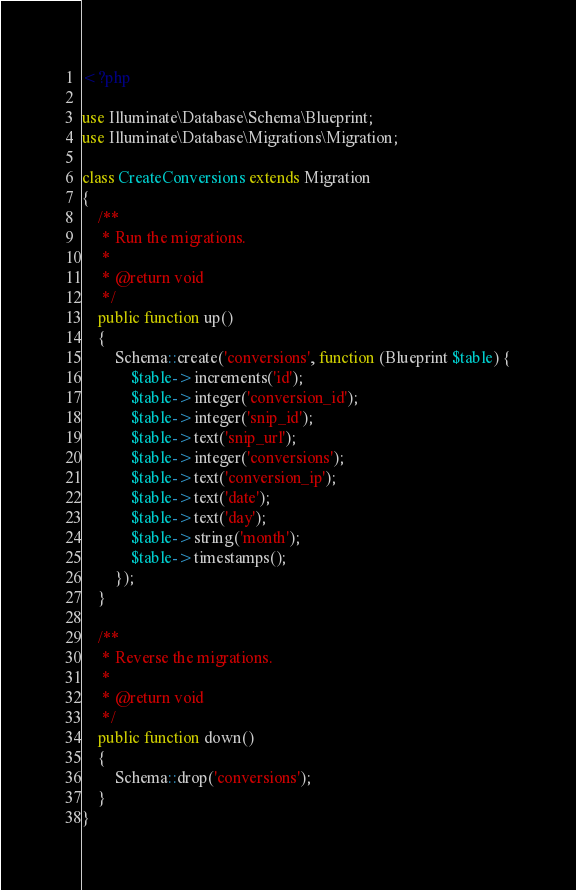<code> <loc_0><loc_0><loc_500><loc_500><_PHP_><?php

use Illuminate\Database\Schema\Blueprint;
use Illuminate\Database\Migrations\Migration;

class CreateConversions extends Migration
{
    /**
     * Run the migrations.
     *
     * @return void
     */
    public function up()
    {
        Schema::create('conversions', function (Blueprint $table) {
            $table->increments('id');
            $table->integer('conversion_id');
            $table->integer('snip_id');
            $table->text('snip_url');
            $table->integer('conversions');
            $table->text('conversion_ip');
            $table->text('date');
            $table->text('day');
            $table->string('month');
            $table->timestamps();
        });
    }

    /**
     * Reverse the migrations.
     *
     * @return void
     */
    public function down()
    {
        Schema::drop('conversions');
    }
}
</code> 